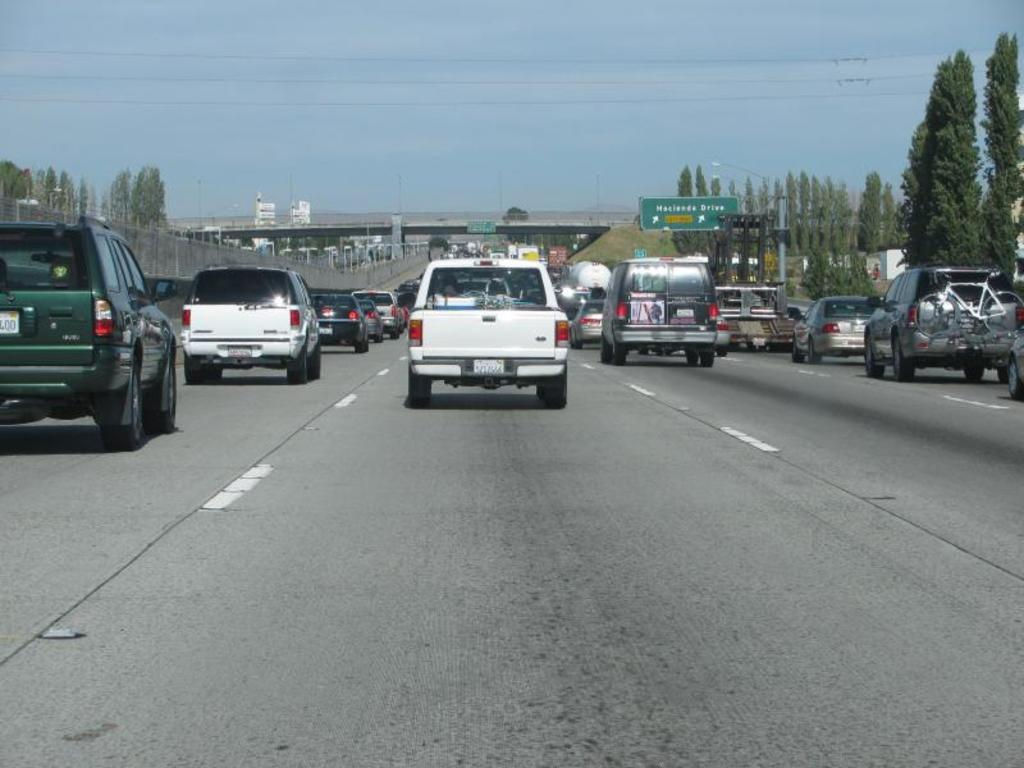What type of vehicles can be seen on the road in the image? There are cars on the road in the image. What objects can be seen in the background of the image? There are boards, lights, poles, a bridge, wires, trees, and the sky visible in the background. What time of day is it in the image, and who is kissing in the afternoon? The time of day is not mentioned in the image, and there is no indication of anyone kissing. 